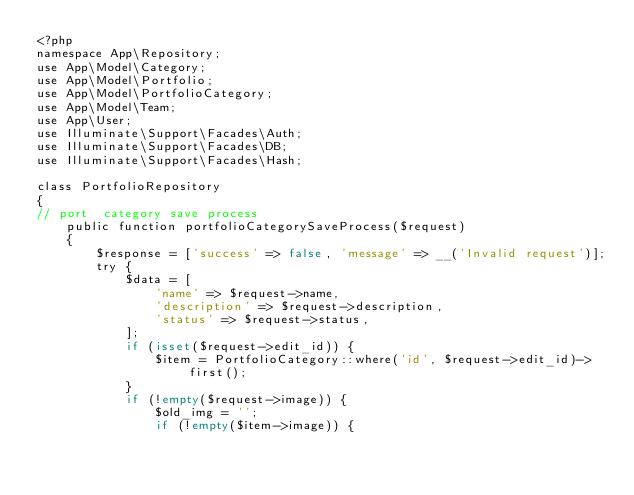<code> <loc_0><loc_0><loc_500><loc_500><_PHP_><?php
namespace App\Repository;
use App\Model\Category;
use App\Model\Portfolio;
use App\Model\PortfolioCategory;
use App\Model\Team;
use App\User;
use Illuminate\Support\Facades\Auth;
use Illuminate\Support\Facades\DB;
use Illuminate\Support\Facades\Hash;

class PortfolioRepository
{
// port  category save process
    public function portfolioCategorySaveProcess($request)
    {
        $response = ['success' => false, 'message' => __('Invalid request')];
        try {
            $data = [
                'name' => $request->name,
                'description' => $request->description,
                'status' => $request->status,
            ];
            if (isset($request->edit_id)) {
                $item = PortfolioCategory::where('id', $request->edit_id)->first();
            }
            if (!empty($request->image)) {
                $old_img = '';
                if (!empty($item->image)) {</code> 